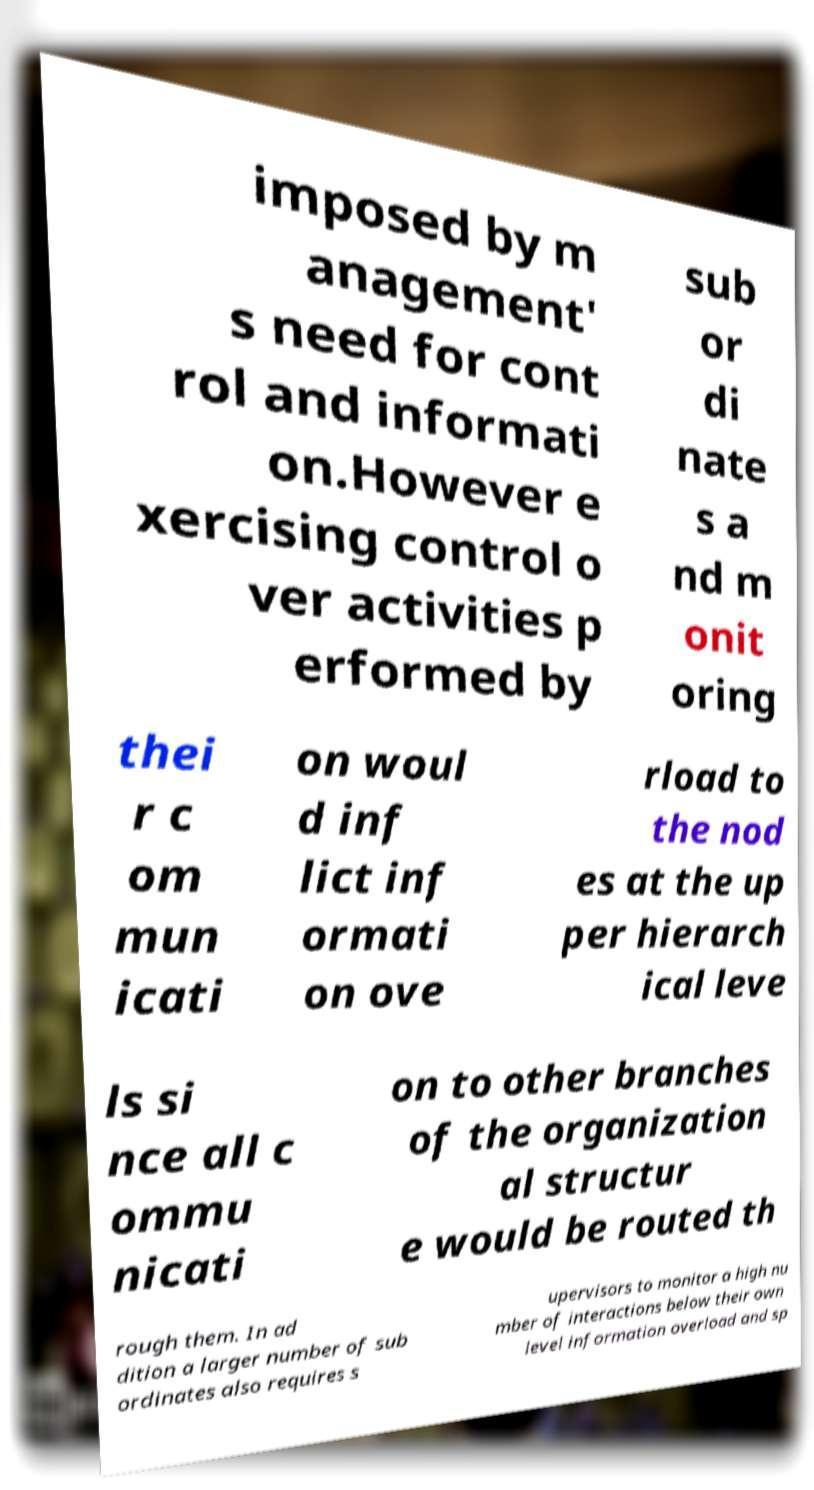Could you extract and type out the text from this image? imposed by m anagement' s need for cont rol and informati on.However e xercising control o ver activities p erformed by sub or di nate s a nd m onit oring thei r c om mun icati on woul d inf lict inf ormati on ove rload to the nod es at the up per hierarch ical leve ls si nce all c ommu nicati on to other branches of the organization al structur e would be routed th rough them. In ad dition a larger number of sub ordinates also requires s upervisors to monitor a high nu mber of interactions below their own level information overload and sp 